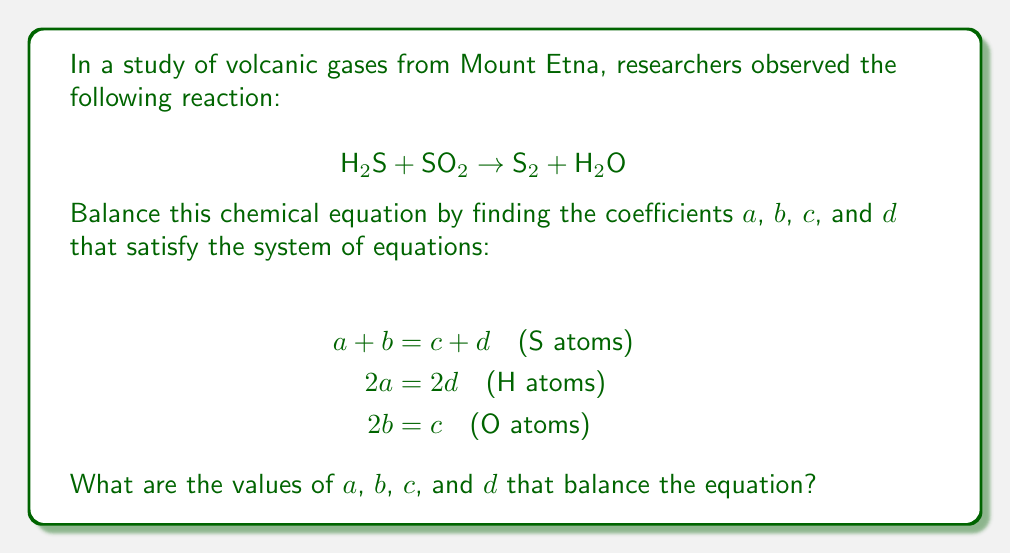Teach me how to tackle this problem. To solve this system of equations, we'll use substitution and elimination methods:

1) From the second equation, we can see that $a = d$.

2) From the third equation, we can express $c$ in terms of $b$: $c = 2b$.

3) Substituting these into the first equation:
   $$ a + b = 2b + a $$

4) Simplifying:
   $$ b = b $$

This means that the first equation is always satisfied regardless of the values of $a$ and $b$, as long as $c = 2b$ and $a = d$.

5) To find a specific solution, we can choose $a = d = 2$ and $b = 1$.

6) Then, $c = 2b = 2(1) = 2$.

7) Verifying the solution:
   - S atoms: $2 + 1 = 2 + 2$
   - H atoms: $2(2) = 2(2)$
   - O atoms: $2(1) = 2$

Therefore, the balanced equation is:

$$ 2\text{H}_2\text{S} + \text{SO}_2 \rightarrow 2\text{S}_2 + 2\text{H}_2\text{O} $$

The coefficients are $a = 2$, $b = 1$, $c = 2$, and $d = 2$.
Answer: $a = 2$, $b = 1$, $c = 2$, $d = 2$ 